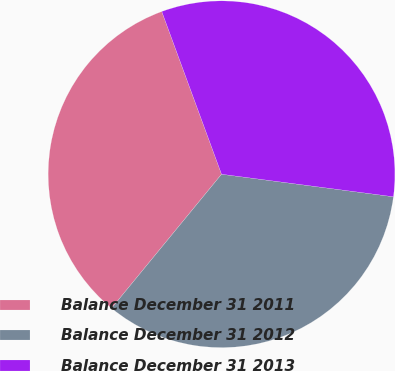Convert chart to OTSL. <chart><loc_0><loc_0><loc_500><loc_500><pie_chart><fcel>Balance December 31 2011<fcel>Balance December 31 2012<fcel>Balance December 31 2013<nl><fcel>33.46%<fcel>33.87%<fcel>32.68%<nl></chart> 